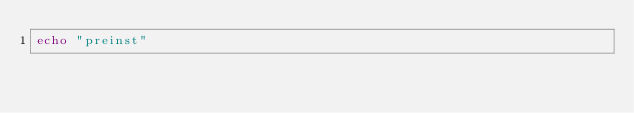<code> <loc_0><loc_0><loc_500><loc_500><_Bash_>echo "preinst"
</code> 